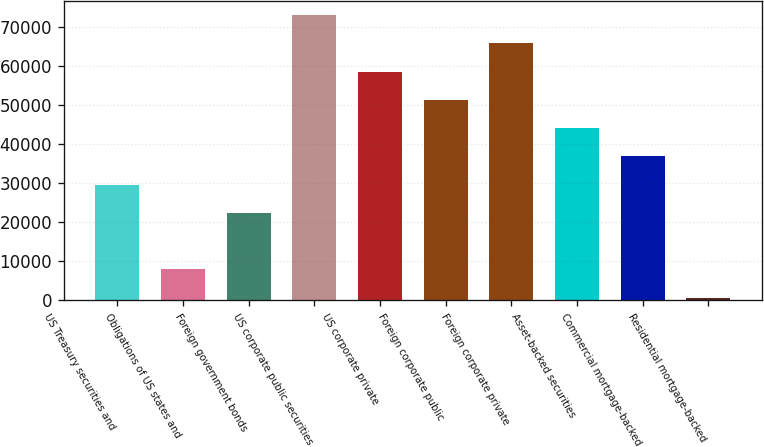<chart> <loc_0><loc_0><loc_500><loc_500><bar_chart><fcel>US Treasury securities and<fcel>Obligations of US states and<fcel>Foreign government bonds<fcel>US corporate public securities<fcel>US corporate private<fcel>Foreign corporate public<fcel>Foreign corporate private<fcel>Asset-backed securities<fcel>Commercial mortgage-backed<fcel>Residential mortgage-backed<nl><fcel>29566.2<fcel>7899.3<fcel>22343.9<fcel>72900<fcel>58455.4<fcel>51233.1<fcel>65677.7<fcel>44010.8<fcel>36788.5<fcel>677<nl></chart> 